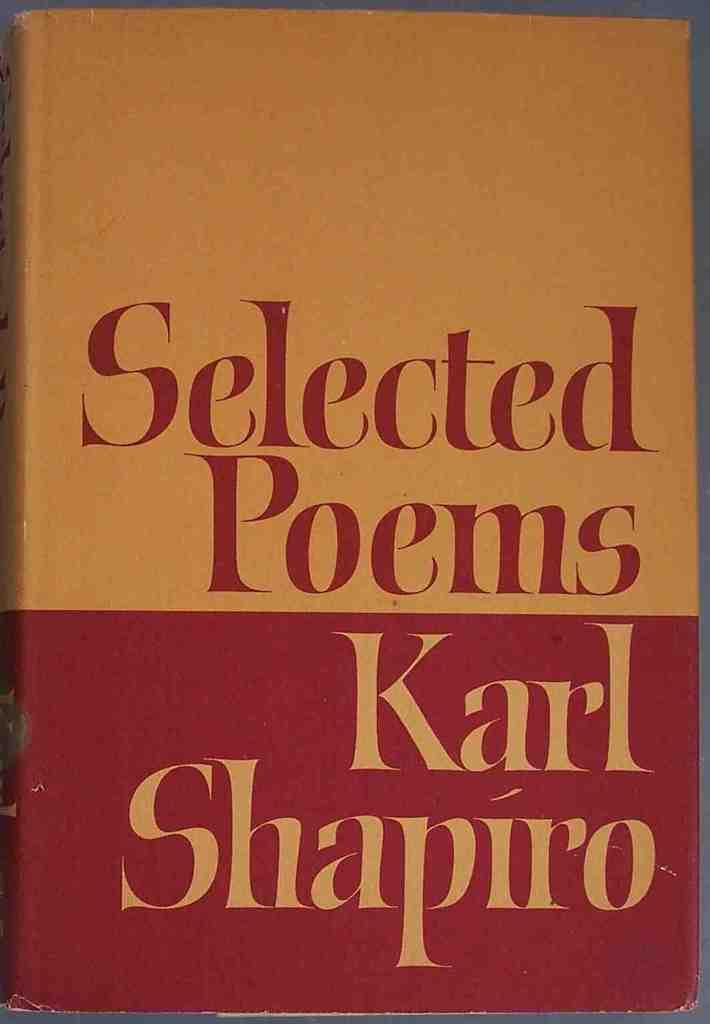Provide a one-sentence caption for the provided image. The book shown has a collection of different poems. 